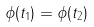Convert formula to latex. <formula><loc_0><loc_0><loc_500><loc_500>\phi ( t _ { 1 } ) = \phi ( t _ { 2 } )</formula> 